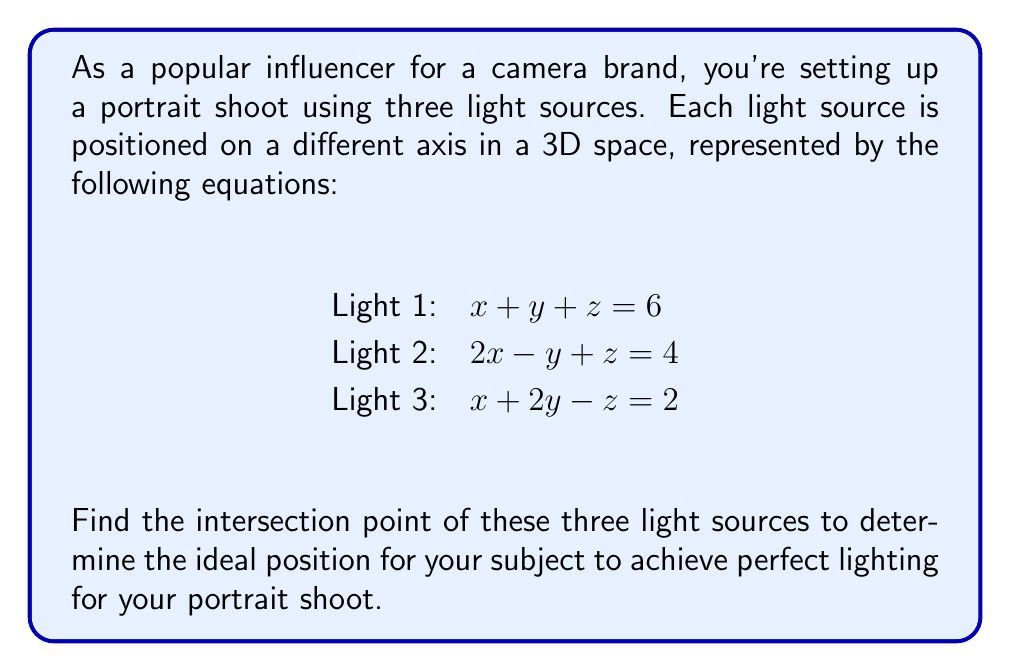Could you help me with this problem? To find the intersection point of the three light sources, we need to solve the system of linear equations:

$$
\begin{cases}
x + y + z = 6 \\
2x - y + z = 4 \\
x + 2y - z = 2
\end{cases}
$$

Let's solve this system using the elimination method:

Step 1: Subtract equation (1) from equation (2) to eliminate z:
$$(2x - y + z) - (x + y + z) = 4 - 6$$
$$x - 2y = -2 \quad \text{(4)}$$

Step 2: Add equation (1) and equation (3) to eliminate z:
$$(x + y + z) + (x + 2y - z) = 6 + 2$$
$$2x + 3y = 8 \quad \text{(5)}$$

Step 3: Multiply equation (4) by 3 and equation (5) by 2:
$$3x - 6y = -6 \quad \text{(6)}$$
$$4x + 6y = 16 \quad \text{(7)}$$

Step 4: Add equations (6) and (7) to eliminate y:
$$(3x - 6y) + (4x + 6y) = -6 + 16$$
$$7x = 10$$

Step 5: Solve for x:
$$x = \frac{10}{7}$$

Step 6: Substitute x into equation (5) to find y:
$$2(\frac{10}{7}) + 3y = 8$$
$$\frac{20}{7} + 3y = 8$$
$$3y = 8 - \frac{20}{7} = \frac{56}{7} - \frac{20}{7} = \frac{36}{7}$$
$$y = \frac{12}{7}$$

Step 7: Substitute x and y into equation (1) to find z:
$$\frac{10}{7} + \frac{12}{7} + z = 6$$
$$\frac{22}{7} + z = 6$$
$$z = 6 - \frac{22}{7} = \frac{42}{7} - \frac{22}{7} = \frac{20}{7}$$

Therefore, the intersection point of the three light sources is $(\frac{10}{7}, \frac{12}{7}, \frac{20}{7})$.
Answer: The ideal position for the subject to achieve perfect lighting is at the point $(\frac{10}{7}, \frac{12}{7}, \frac{20}{7})$ or approximately $(1.43, 1.71, 2.86)$ in the 3D space. 